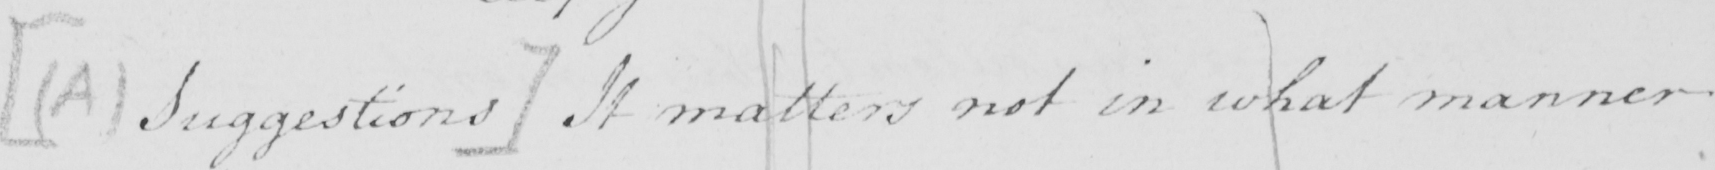Can you read and transcribe this handwriting? [  ( A )  Suggestions ]  It matters not in what manner 